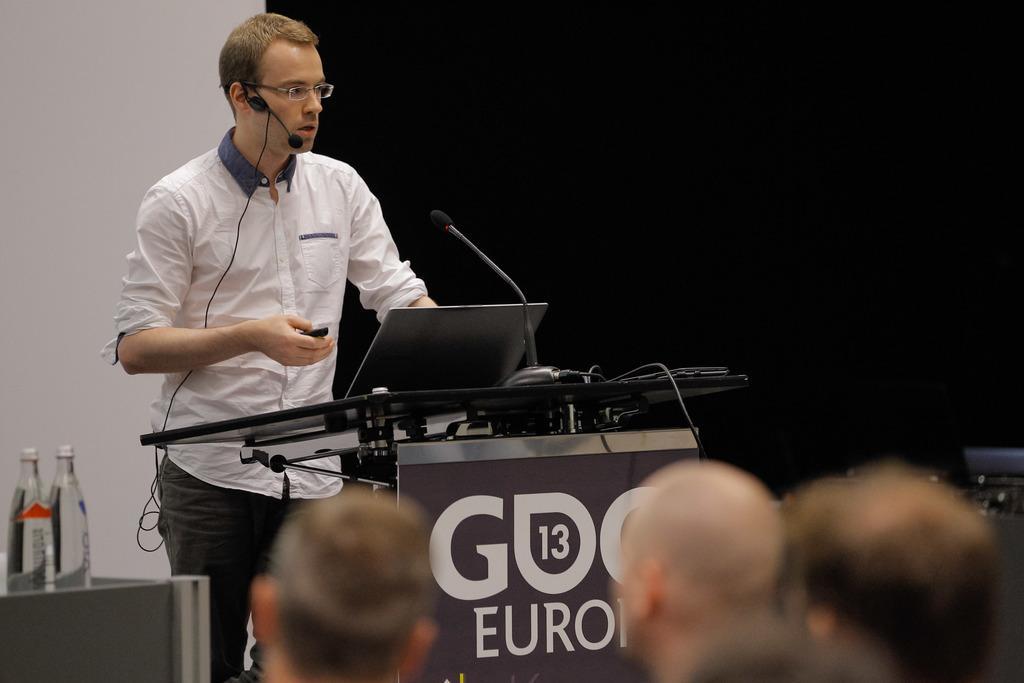How would you summarize this image in a sentence or two? The man on the left side of the picture wearing a white shirt is standing in front of the podium and he is talking on the microphone. He is holding the remote in his hand and he is operating the laptop which is placed on the podium. Beside him, we see a table on which water bottles are placed. At the bottom of the picture, we see people sitting on the chairs and listening to the man in the opposite side. Behind him, we see a black color sheet and behind that, we see a white wall. This picture might be clicked in a conference hall. 